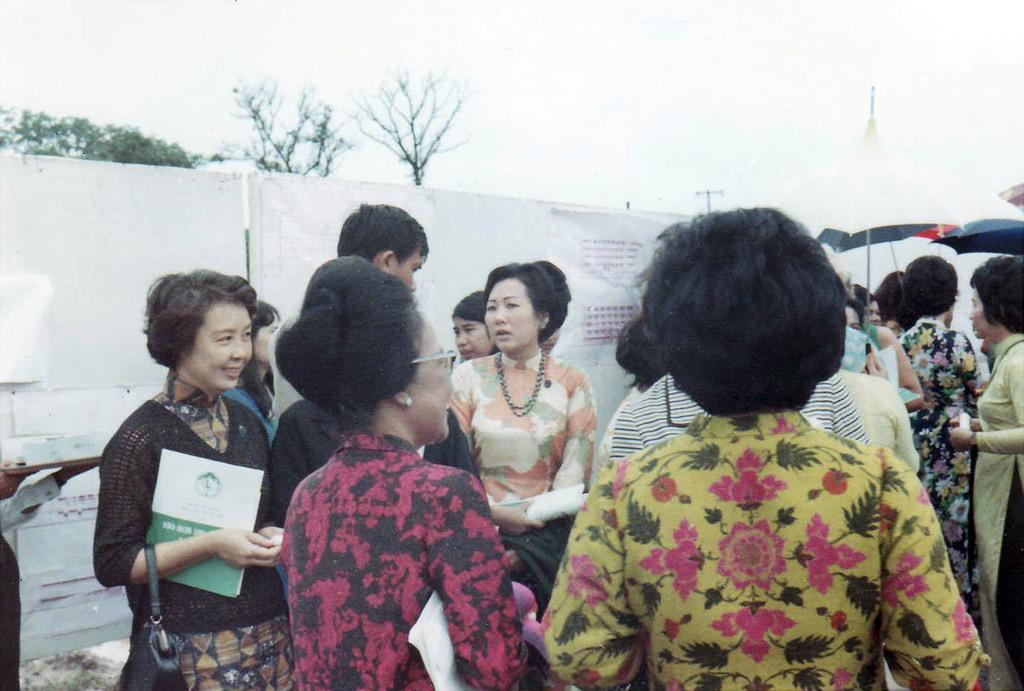What are the women in the image doing? The women are standing on the road in the image. What can be seen in the background of the image? There is an umbrella, boards, trees, and the sky visible in the background of the image. What type of insurance policy is being discussed by the women in the image? There is no indication in the image that the women are discussing any insurance policies. 